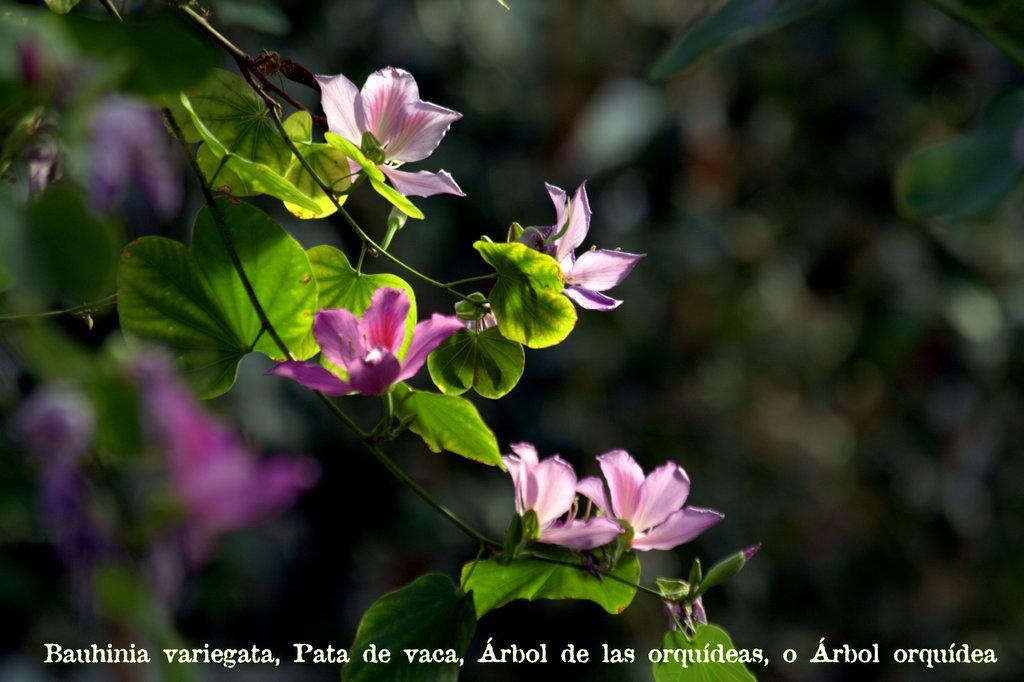Could you give a brief overview of what you see in this image? In the image we can see flowers, leaves and the background is blurred. On the bottom part of the image we can see the watermark. 